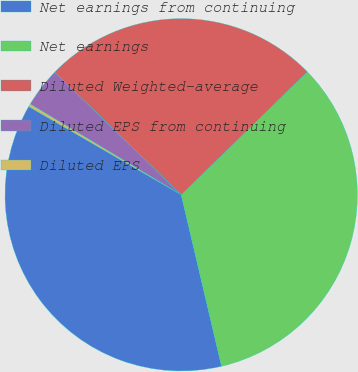Convert chart. <chart><loc_0><loc_0><loc_500><loc_500><pie_chart><fcel>Net earnings from continuing<fcel>Net earnings<fcel>Diluted Weighted-average<fcel>Diluted EPS from continuing<fcel>Diluted EPS<nl><fcel>37.02%<fcel>33.63%<fcel>25.44%<fcel>3.64%<fcel>0.26%<nl></chart> 